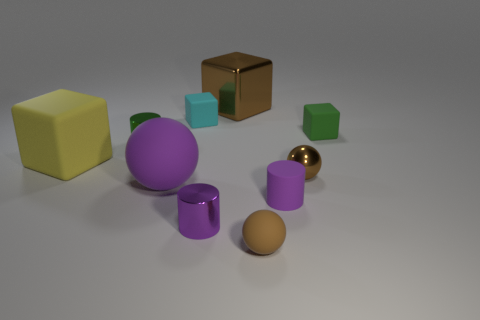Subtract 1 cubes. How many cubes are left? 3 Subtract all gray blocks. Subtract all green cylinders. How many blocks are left? 4 Add 7 purple rubber spheres. How many purple rubber spheres exist? 8 Subtract 0 gray spheres. How many objects are left? 10 Subtract all cylinders. How many objects are left? 7 Subtract all small metal objects. Subtract all brown objects. How many objects are left? 4 Add 5 cyan matte things. How many cyan matte things are left? 6 